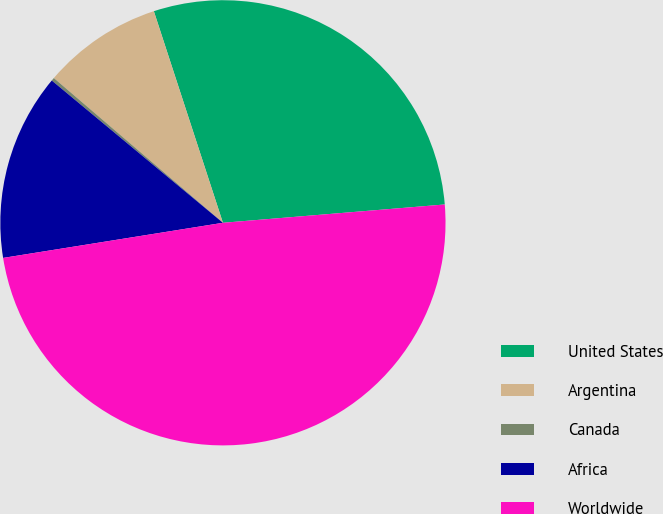Convert chart. <chart><loc_0><loc_0><loc_500><loc_500><pie_chart><fcel>United States<fcel>Argentina<fcel>Canada<fcel>Africa<fcel>Worldwide<nl><fcel>28.71%<fcel>8.71%<fcel>0.23%<fcel>13.56%<fcel>48.79%<nl></chart> 